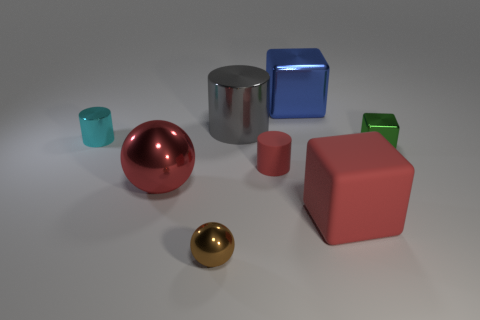How many gray metallic cylinders are in front of the large metallic thing that is in front of the small cylinder that is to the left of the tiny ball?
Give a very brief answer. 0. There is a cube that is the same size as the blue object; what is it made of?
Your answer should be very brief. Rubber. Is there a brown sphere that has the same size as the gray cylinder?
Your answer should be compact. No. What is the color of the tiny matte cylinder?
Your answer should be very brief. Red. There is a tiny shiny thing that is to the left of the tiny shiny object that is in front of the small red cylinder; what is its color?
Make the answer very short. Cyan. What is the shape of the tiny thing to the right of the matte object in front of the small red object behind the big matte thing?
Your answer should be compact. Cube. What number of cylinders have the same material as the red cube?
Ensure brevity in your answer.  1. There is a red rubber object that is on the left side of the blue shiny thing; what number of tiny cyan cylinders are on the right side of it?
Your answer should be compact. 0. What number of large red shiny objects are there?
Ensure brevity in your answer.  1. Are the large blue block and the red thing that is left of the gray shiny cylinder made of the same material?
Offer a very short reply. Yes. 